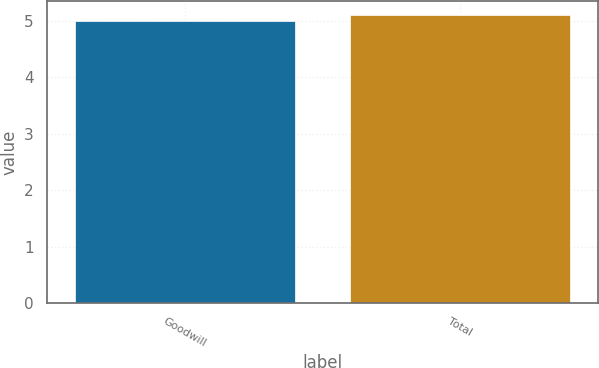Convert chart to OTSL. <chart><loc_0><loc_0><loc_500><loc_500><bar_chart><fcel>Goodwill<fcel>Total<nl><fcel>5<fcel>5.1<nl></chart> 